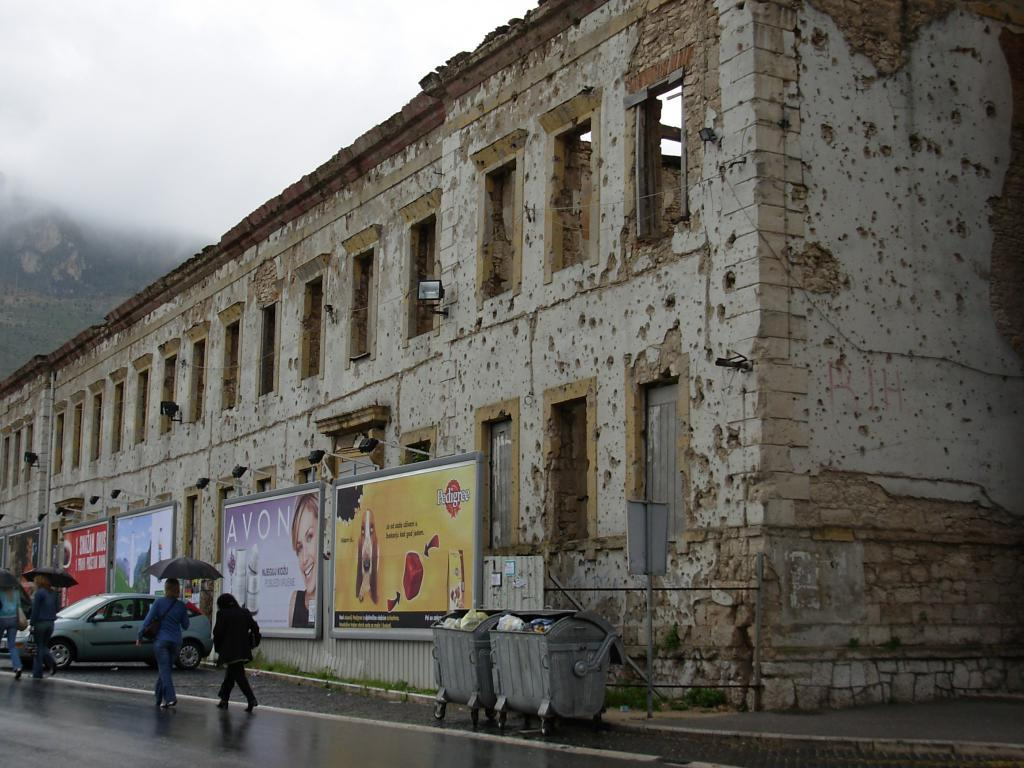Provide a one-sentence caption for the provided image. A damaged building with signs for Avon and Pedigree on the side. 